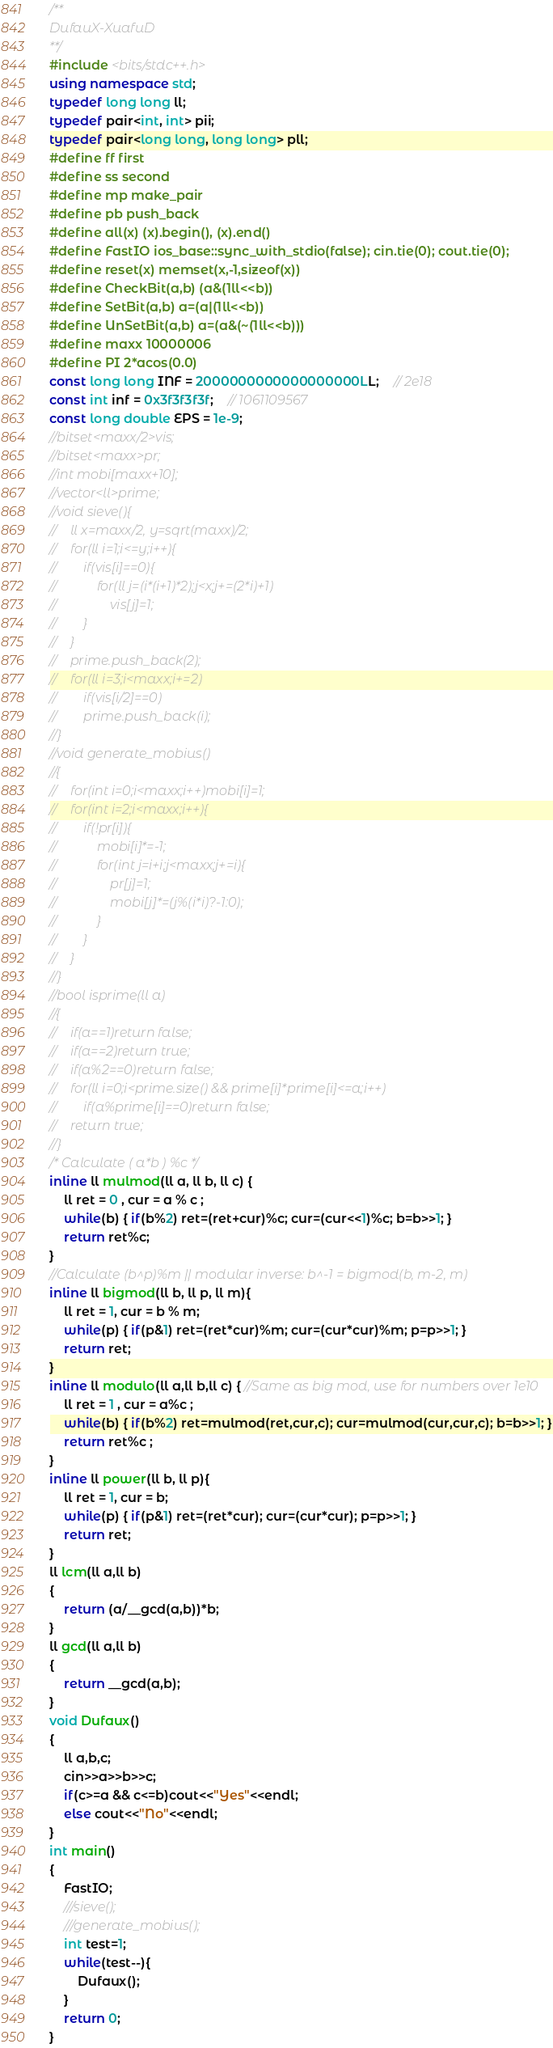<code> <loc_0><loc_0><loc_500><loc_500><_C++_>/**
DufauX-XuafuD
**/
#include <bits/stdc++.h>
using namespace std;
typedef long long ll;
typedef pair<int, int> pii;
typedef pair<long long, long long> pll;
#define ff first
#define ss second
#define mp make_pair
#define pb push_back
#define all(x) (x).begin(), (x).end()
#define FastIO ios_base::sync_with_stdio(false); cin.tie(0); cout.tie(0);
#define reset(x) memset(x,-1,sizeof(x))
#define CheckBit(a,b) (a&(1ll<<b))
#define SetBit(a,b) a=(a|(1ll<<b))
#define UnSetBit(a,b) a=(a&(~(1ll<<b)))
#define maxx 10000006
#define PI 2*acos(0.0)
const long long INF = 2000000000000000000LL;	// 2e18
const int inf = 0x3f3f3f3f;	// 1061109567
const long double EPS = 1e-9;
//bitset<maxx/2>vis;
//bitset<maxx>pr;
//int mobi[maxx+10];
//vector<ll>prime;
//void sieve(){
//    ll x=maxx/2, y=sqrt(maxx)/2;
//    for(ll i=1;i<=y;i++){
//        if(vis[i]==0){
//            for(ll j=(i*(i+1)*2);j<x;j+=(2*i)+1)
//                vis[j]=1;
//        }
//    }
//    prime.push_back(2);
//    for(ll i=3;i<maxx;i+=2)
//        if(vis[i/2]==0)
//        prime.push_back(i);
//}
//void generate_mobius()
//{
//    for(int i=0;i<maxx;i++)mobi[i]=1;
//    for(int i=2;i<maxx;i++){
//        if(!pr[i]){
//            mobi[i]*=-1;
//            for(int j=i+i;j<maxx;j+=i){
//                pr[j]=1;
//                mobi[j]*=(j%(i*i)?-1:0);
//            }
//        }
//    }
//}
//bool isprime(ll a)
//{
//    if(a==1)return false;
//    if(a==2)return true;
//    if(a%2==0)return false;
//    for(ll i=0;i<prime.size() && prime[i]*prime[i]<=a;i++)
//        if(a%prime[i]==0)return false;
//    return true;
//}
/* Calculate ( a*b ) %c */
inline ll mulmod(ll a, ll b, ll c) {
    ll ret = 0 , cur = a % c ;
    while(b) { if(b%2) ret=(ret+cur)%c; cur=(cur<<1)%c; b=b>>1; }
    return ret%c;
}
//Calculate (b^p)%m || modular inverse: b^-1 = bigmod(b, m-2, m)
inline ll bigmod(ll b, ll p, ll m){
    ll ret = 1, cur = b % m;
    while(p) { if(p&1) ret=(ret*cur)%m; cur=(cur*cur)%m; p=p>>1; }
    return ret;
}
inline ll modulo(ll a,ll b,ll c) { //Same as big mod, use for numbers over 1e10
    ll ret = 1 , cur = a%c ;
    while(b) { if(b%2) ret=mulmod(ret,cur,c); cur=mulmod(cur,cur,c); b=b>>1; }
    return ret%c ;
}
inline ll power(ll b, ll p){
    ll ret = 1, cur = b;
    while(p) { if(p&1) ret=(ret*cur); cur=(cur*cur); p=p>>1; }
    return ret;
}
ll lcm(ll a,ll b)
{
    return (a/__gcd(a,b))*b;
}
ll gcd(ll a,ll b)
{
    return __gcd(a,b);
}
void Dufaux()
{
    ll a,b,c;
    cin>>a>>b>>c;
    if(c>=a && c<=b)cout<<"Yes"<<endl;
    else cout<<"No"<<endl;
}
int main()
{
    FastIO;
	///sieve();
	///generate_mobius();
	int test=1;
	while(test--){
        Dufaux();
	}
	return 0;
}



</code> 